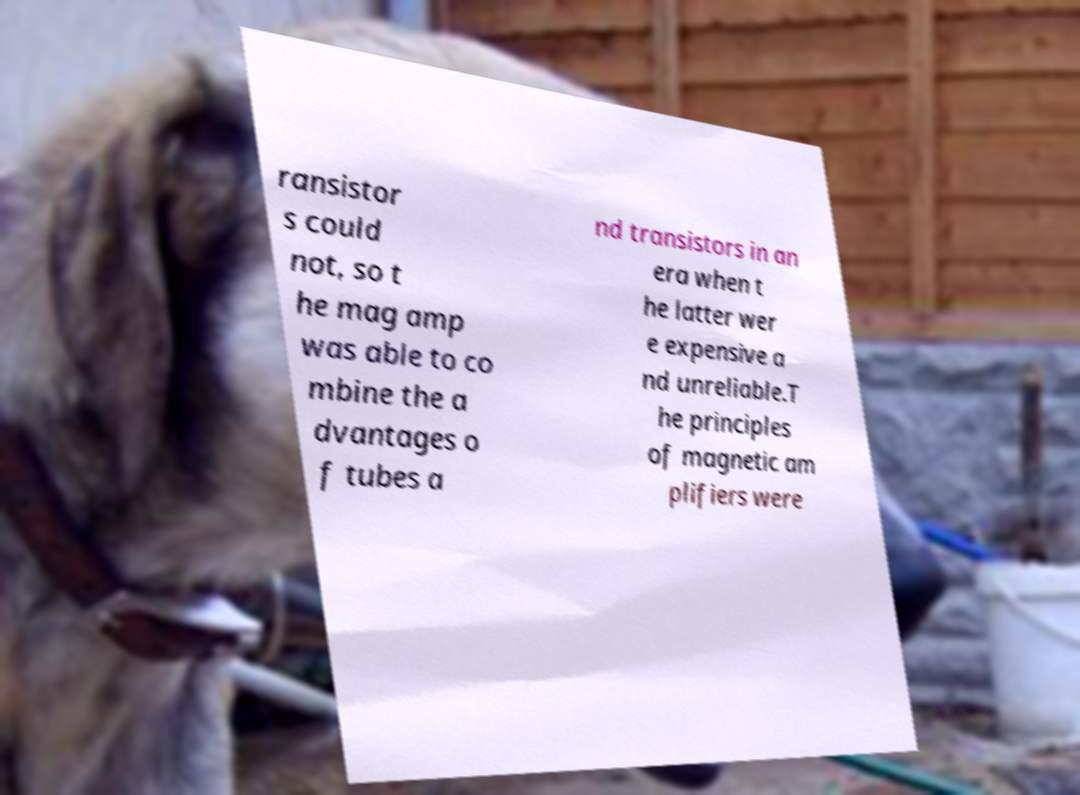Can you read and provide the text displayed in the image?This photo seems to have some interesting text. Can you extract and type it out for me? ransistor s could not, so t he mag amp was able to co mbine the a dvantages o f tubes a nd transistors in an era when t he latter wer e expensive a nd unreliable.T he principles of magnetic am plifiers were 